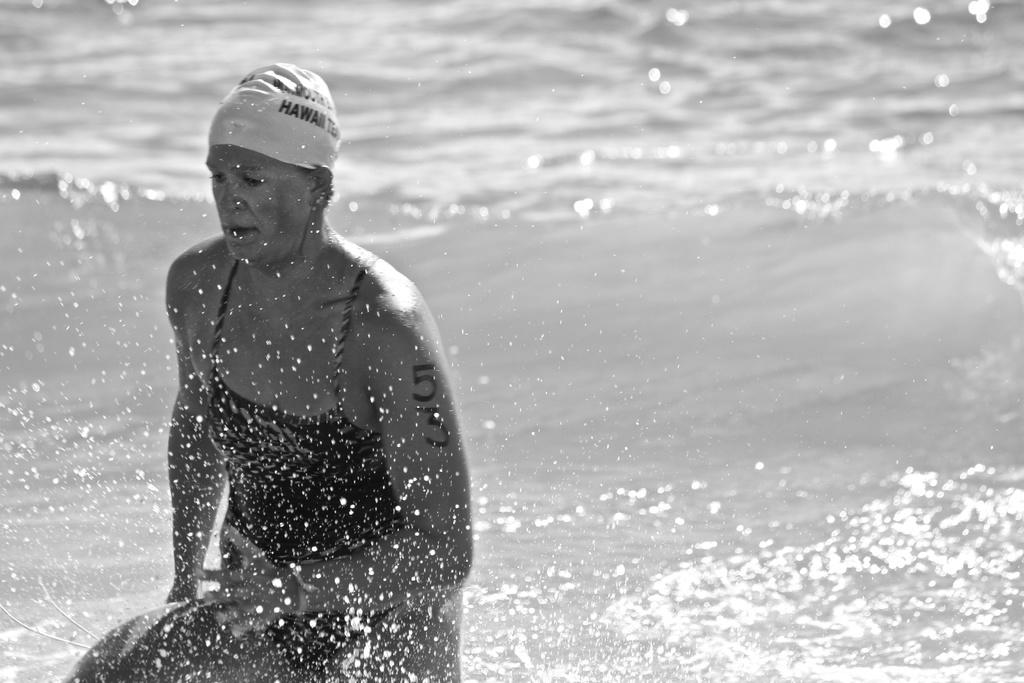Who is the main subject in the image? There is a woman in the image. Where is the woman located in the image? The woman is located towards the bottom of the image. What is the woman wearing on her head? The woman is wearing a cap. What is written or printed on the cap? There is text on the cap. What can be seen in the background of the image? There is water visible in the background of the image. What type of alarm is the woman holding in the image? There is no alarm present in the image. How many fingers is the woman holding up in the image? There is no indication of the woman holding up any fingers in the image. 